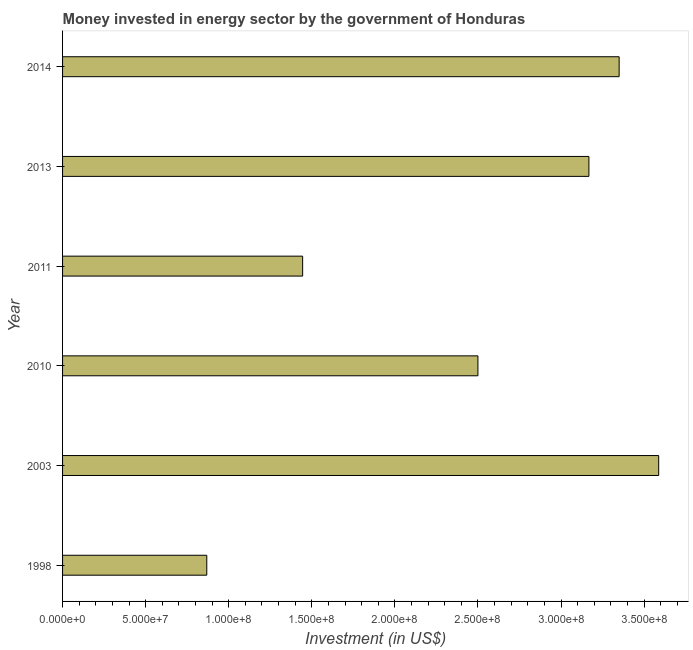Does the graph contain grids?
Offer a terse response. No. What is the title of the graph?
Your response must be concise. Money invested in energy sector by the government of Honduras. What is the label or title of the X-axis?
Your answer should be compact. Investment (in US$). What is the investment in energy in 2013?
Give a very brief answer. 3.17e+08. Across all years, what is the maximum investment in energy?
Make the answer very short. 3.59e+08. Across all years, what is the minimum investment in energy?
Provide a short and direct response. 8.68e+07. In which year was the investment in energy maximum?
Offer a terse response. 2003. In which year was the investment in energy minimum?
Keep it short and to the point. 1998. What is the sum of the investment in energy?
Offer a terse response. 1.49e+09. What is the difference between the investment in energy in 1998 and 2013?
Offer a terse response. -2.30e+08. What is the average investment in energy per year?
Your response must be concise. 2.49e+08. What is the median investment in energy?
Offer a terse response. 2.83e+08. What is the ratio of the investment in energy in 1998 to that in 2014?
Your answer should be compact. 0.26. What is the difference between the highest and the second highest investment in energy?
Provide a succinct answer. 2.38e+07. What is the difference between the highest and the lowest investment in energy?
Provide a short and direct response. 2.72e+08. Are the values on the major ticks of X-axis written in scientific E-notation?
Give a very brief answer. Yes. What is the Investment (in US$) in 1998?
Ensure brevity in your answer.  8.68e+07. What is the Investment (in US$) in 2003?
Your response must be concise. 3.59e+08. What is the Investment (in US$) in 2010?
Your answer should be very brief. 2.50e+08. What is the Investment (in US$) of 2011?
Make the answer very short. 1.44e+08. What is the Investment (in US$) of 2013?
Provide a short and direct response. 3.17e+08. What is the Investment (in US$) in 2014?
Offer a very short reply. 3.35e+08. What is the difference between the Investment (in US$) in 1998 and 2003?
Your answer should be compact. -2.72e+08. What is the difference between the Investment (in US$) in 1998 and 2010?
Give a very brief answer. -1.63e+08. What is the difference between the Investment (in US$) in 1998 and 2011?
Ensure brevity in your answer.  -5.77e+07. What is the difference between the Investment (in US$) in 1998 and 2013?
Keep it short and to the point. -2.30e+08. What is the difference between the Investment (in US$) in 1998 and 2014?
Give a very brief answer. -2.48e+08. What is the difference between the Investment (in US$) in 2003 and 2010?
Ensure brevity in your answer.  1.09e+08. What is the difference between the Investment (in US$) in 2003 and 2011?
Make the answer very short. 2.14e+08. What is the difference between the Investment (in US$) in 2003 and 2013?
Ensure brevity in your answer.  4.20e+07. What is the difference between the Investment (in US$) in 2003 and 2014?
Offer a terse response. 2.38e+07. What is the difference between the Investment (in US$) in 2010 and 2011?
Make the answer very short. 1.06e+08. What is the difference between the Investment (in US$) in 2010 and 2013?
Provide a succinct answer. -6.68e+07. What is the difference between the Investment (in US$) in 2010 and 2014?
Provide a succinct answer. -8.50e+07. What is the difference between the Investment (in US$) in 2011 and 2013?
Provide a succinct answer. -1.72e+08. What is the difference between the Investment (in US$) in 2011 and 2014?
Your answer should be compact. -1.90e+08. What is the difference between the Investment (in US$) in 2013 and 2014?
Offer a terse response. -1.82e+07. What is the ratio of the Investment (in US$) in 1998 to that in 2003?
Ensure brevity in your answer.  0.24. What is the ratio of the Investment (in US$) in 1998 to that in 2010?
Provide a short and direct response. 0.35. What is the ratio of the Investment (in US$) in 1998 to that in 2011?
Your response must be concise. 0.6. What is the ratio of the Investment (in US$) in 1998 to that in 2013?
Make the answer very short. 0.27. What is the ratio of the Investment (in US$) in 1998 to that in 2014?
Your answer should be very brief. 0.26. What is the ratio of the Investment (in US$) in 2003 to that in 2010?
Give a very brief answer. 1.44. What is the ratio of the Investment (in US$) in 2003 to that in 2011?
Ensure brevity in your answer.  2.48. What is the ratio of the Investment (in US$) in 2003 to that in 2013?
Make the answer very short. 1.13. What is the ratio of the Investment (in US$) in 2003 to that in 2014?
Keep it short and to the point. 1.07. What is the ratio of the Investment (in US$) in 2010 to that in 2011?
Your answer should be very brief. 1.73. What is the ratio of the Investment (in US$) in 2010 to that in 2013?
Provide a succinct answer. 0.79. What is the ratio of the Investment (in US$) in 2010 to that in 2014?
Provide a short and direct response. 0.75. What is the ratio of the Investment (in US$) in 2011 to that in 2013?
Your answer should be compact. 0.46. What is the ratio of the Investment (in US$) in 2011 to that in 2014?
Provide a succinct answer. 0.43. What is the ratio of the Investment (in US$) in 2013 to that in 2014?
Keep it short and to the point. 0.95. 